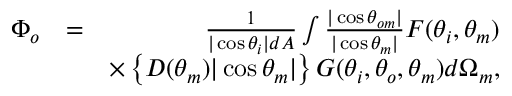<formula> <loc_0><loc_0><loc_500><loc_500>\begin{array} { r l r } { \Phi _ { o } } & { = } & { \frac { 1 } { | \cos \theta _ { i } | d A } \int \frac { | \cos \theta _ { o m } | } { | \cos \theta _ { m } | } F ( \theta _ { i } , \theta _ { m } ) } \\ & { \times \left \{ D ( \theta _ { m } ) | \cos \theta _ { m } | \right \} G ( \theta _ { i } , \theta _ { o } , \theta _ { m } ) d \Omega _ { m } , } \end{array}</formula> 